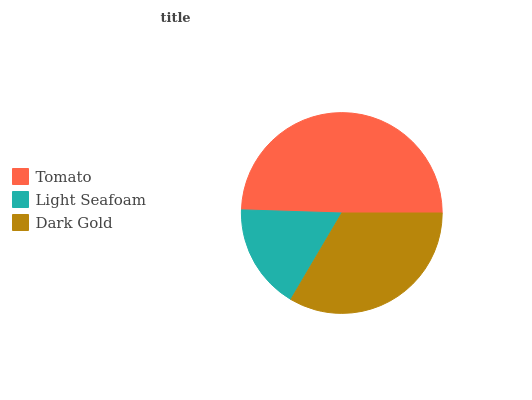Is Light Seafoam the minimum?
Answer yes or no. Yes. Is Tomato the maximum?
Answer yes or no. Yes. Is Dark Gold the minimum?
Answer yes or no. No. Is Dark Gold the maximum?
Answer yes or no. No. Is Dark Gold greater than Light Seafoam?
Answer yes or no. Yes. Is Light Seafoam less than Dark Gold?
Answer yes or no. Yes. Is Light Seafoam greater than Dark Gold?
Answer yes or no. No. Is Dark Gold less than Light Seafoam?
Answer yes or no. No. Is Dark Gold the high median?
Answer yes or no. Yes. Is Dark Gold the low median?
Answer yes or no. Yes. Is Light Seafoam the high median?
Answer yes or no. No. Is Tomato the low median?
Answer yes or no. No. 